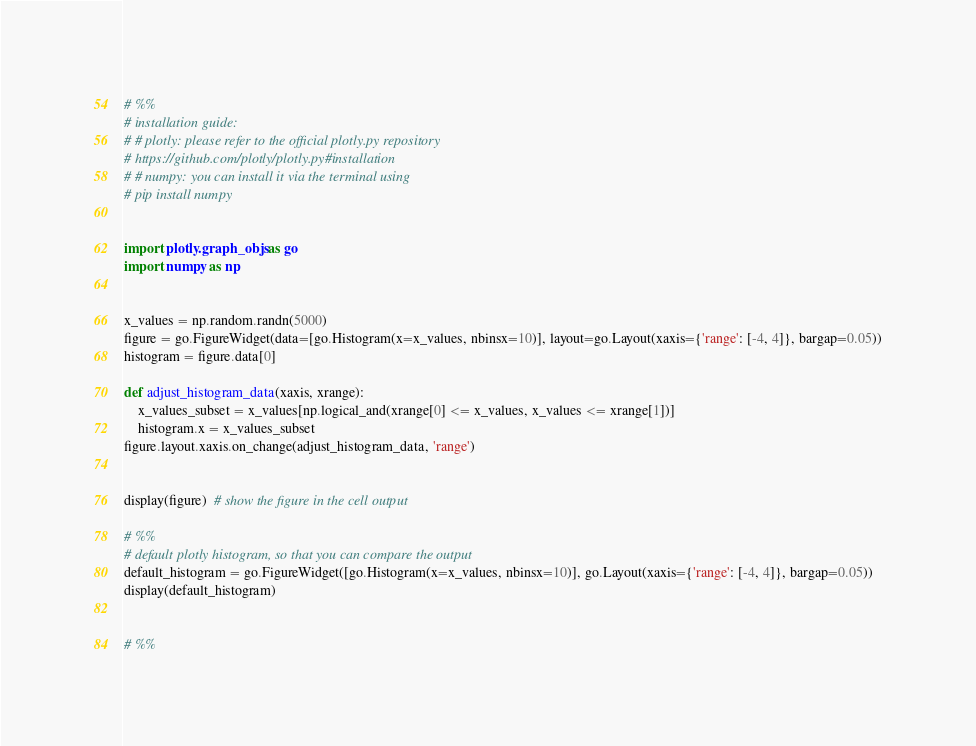<code> <loc_0><loc_0><loc_500><loc_500><_Python_># %%
# installation guide:
# # plotly: please refer to the official plotly.py repository
# https://github.com/plotly/plotly.py#installation
# # numpy: you can install it via the terminal using
# pip install numpy


import plotly.graph_objs as go
import numpy as np


x_values = np.random.randn(5000)
figure = go.FigureWidget(data=[go.Histogram(x=x_values, nbinsx=10)], layout=go.Layout(xaxis={'range': [-4, 4]}, bargap=0.05))
histogram = figure.data[0]

def adjust_histogram_data(xaxis, xrange):
    x_values_subset = x_values[np.logical_and(xrange[0] <= x_values, x_values <= xrange[1])]
    histogram.x = x_values_subset
figure.layout.xaxis.on_change(adjust_histogram_data, 'range')


display(figure)  # show the figure in the cell output

# %%
# default plotly histogram, so that you can compare the output
default_histogram = go.FigureWidget([go.Histogram(x=x_values, nbinsx=10)], go.Layout(xaxis={'range': [-4, 4]}, bargap=0.05))
display(default_histogram)


# %%

</code> 